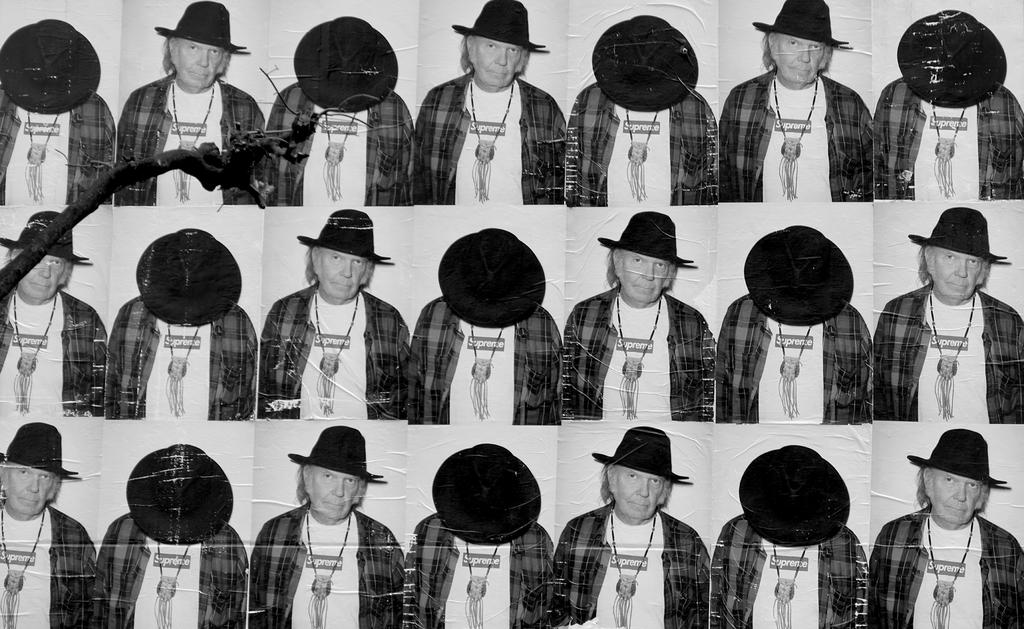What is the color scheme of the image? The image is black and white. What is the main subject of the image? There is a collage of a person in the image. What can be seen on the left side of the image? There is a tree on the left side of the image. How many weeks does the drum last in the image? There is no drum present in the image, so it is not possible to determine how long a drum might last. 